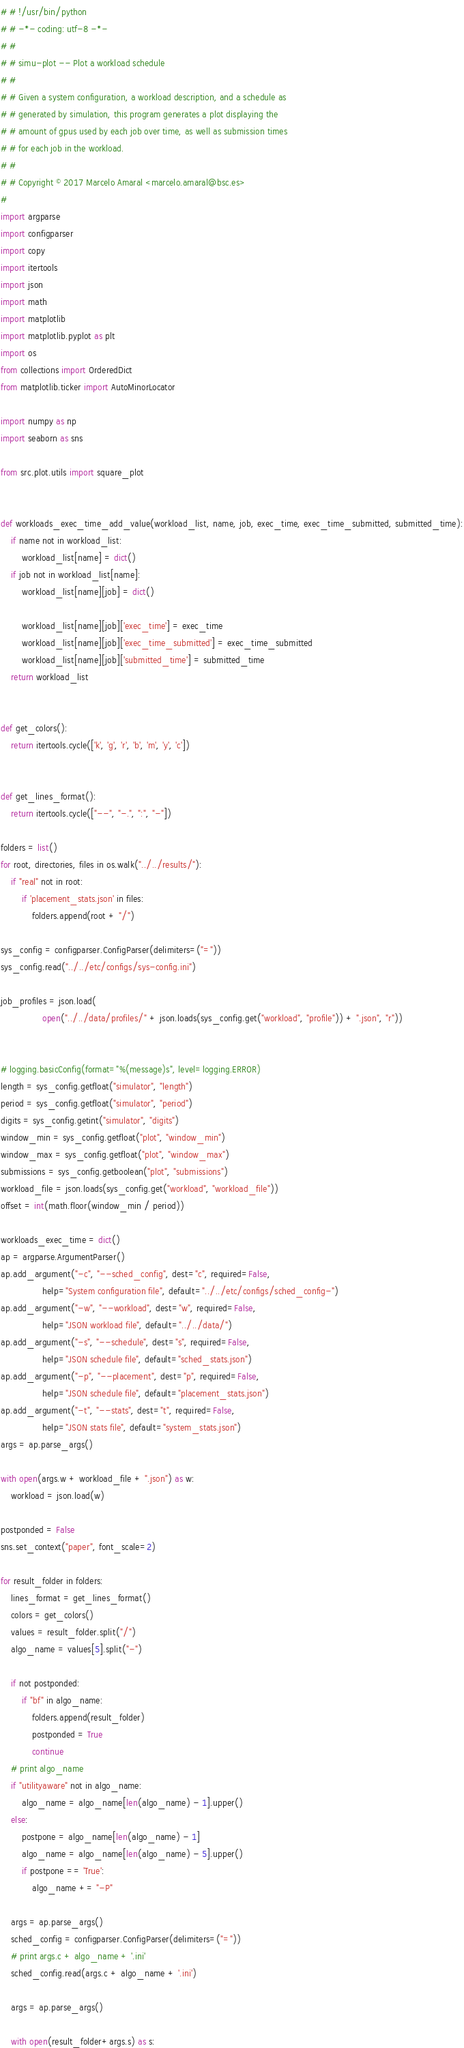Convert code to text. <code><loc_0><loc_0><loc_500><loc_500><_Python_># # !/usr/bin/python
# # -*- coding: utf-8 -*-
# #
# # simu-plot -- Plot a workload schedule
# #
# # Given a system configuration, a workload description, and a schedule as
# # generated by simulation, this program generates a plot displaying the
# # amount of gpus used by each job over time, as well as submission times
# # for each job in the workload.
# #
# # Copyright © 2017 Marcelo Amaral <marcelo.amaral@bsc.es>
#
import argparse
import configparser
import copy
import itertools
import json
import math
import matplotlib
import matplotlib.pyplot as plt
import os
from collections import OrderedDict
from matplotlib.ticker import AutoMinorLocator

import numpy as np
import seaborn as sns

from src.plot.utils import square_plot


def workloads_exec_time_add_value(workload_list, name, job, exec_time, exec_time_submitted, submitted_time):
    if name not in workload_list:
        workload_list[name] = dict()
    if job not in workload_list[name]:
        workload_list[name][job] = dict()

        workload_list[name][job]['exec_time'] = exec_time
        workload_list[name][job]['exec_time_submitted'] = exec_time_submitted
        workload_list[name][job]['submitted_time'] = submitted_time
    return workload_list


def get_colors():
    return itertools.cycle(['k', 'g', 'r', 'b', 'm', 'y', 'c'])


def get_lines_format():
    return itertools.cycle(["--", "-.", ":", "-"])

folders = list()
for root, directories, files in os.walk("../../results/"):
    if "real" not in root:
        if 'placement_stats.json' in files:
            folders.append(root + "/")

sys_config = configparser.ConfigParser(delimiters=("="))
sys_config.read("../../etc/configs/sys-config.ini")

job_profiles = json.load(
                open("../../data/profiles/" + json.loads(sys_config.get("workload", "profile")) + ".json", "r"))


# logging.basicConfig(format="%(message)s", level=logging.ERROR)
length = sys_config.getfloat("simulator", "length")
period = sys_config.getfloat("simulator", "period")
digits = sys_config.getint("simulator", "digits")
window_min = sys_config.getfloat("plot", "window_min")
window_max = sys_config.getfloat("plot", "window_max")
submissions = sys_config.getboolean("plot", "submissions")
workload_file = json.loads(sys_config.get("workload", "workload_file"))
offset = int(math.floor(window_min / period))

workloads_exec_time = dict()
ap = argparse.ArgumentParser()
ap.add_argument("-c", "--sched_config", dest="c", required=False,
                help="System configuration file", default="../../etc/configs/sched_config-")
ap.add_argument("-w", "--workload", dest="w", required=False,
                help="JSON workload file", default="../../data/")
ap.add_argument("-s", "--schedule", dest="s", required=False,
                help="JSON schedule file", default="sched_stats.json")
ap.add_argument("-p", "--placement", dest="p", required=False,
                help="JSON schedule file", default="placement_stats.json")
ap.add_argument("-t", "--stats", dest="t", required=False,
                help="JSON stats file", default="system_stats.json")
args = ap.parse_args()

with open(args.w + workload_file + ".json") as w:
    workload = json.load(w)

postponded = False
sns.set_context("paper", font_scale=2)

for result_folder in folders:
    lines_format = get_lines_format()
    colors = get_colors()
    values = result_folder.split("/")
    algo_name = values[5].split("-")

    if not postponded:
        if "bf" in algo_name:
            folders.append(result_folder)
            postponded = True
            continue
    # print algo_name
    if "utilityaware" not in algo_name:
        algo_name = algo_name[len(algo_name) - 1].upper()
    else:
        postpone = algo_name[len(algo_name) - 1]
        algo_name = algo_name[len(algo_name) - 5].upper()
        if postpone == 'True':
            algo_name += "-P"

    args = ap.parse_args()
    sched_config = configparser.ConfigParser(delimiters=("="))
    # print args.c + algo_name + '.ini'
    sched_config.read(args.c + algo_name + '.ini')

    args = ap.parse_args()

    with open(result_folder+args.s) as s:</code> 